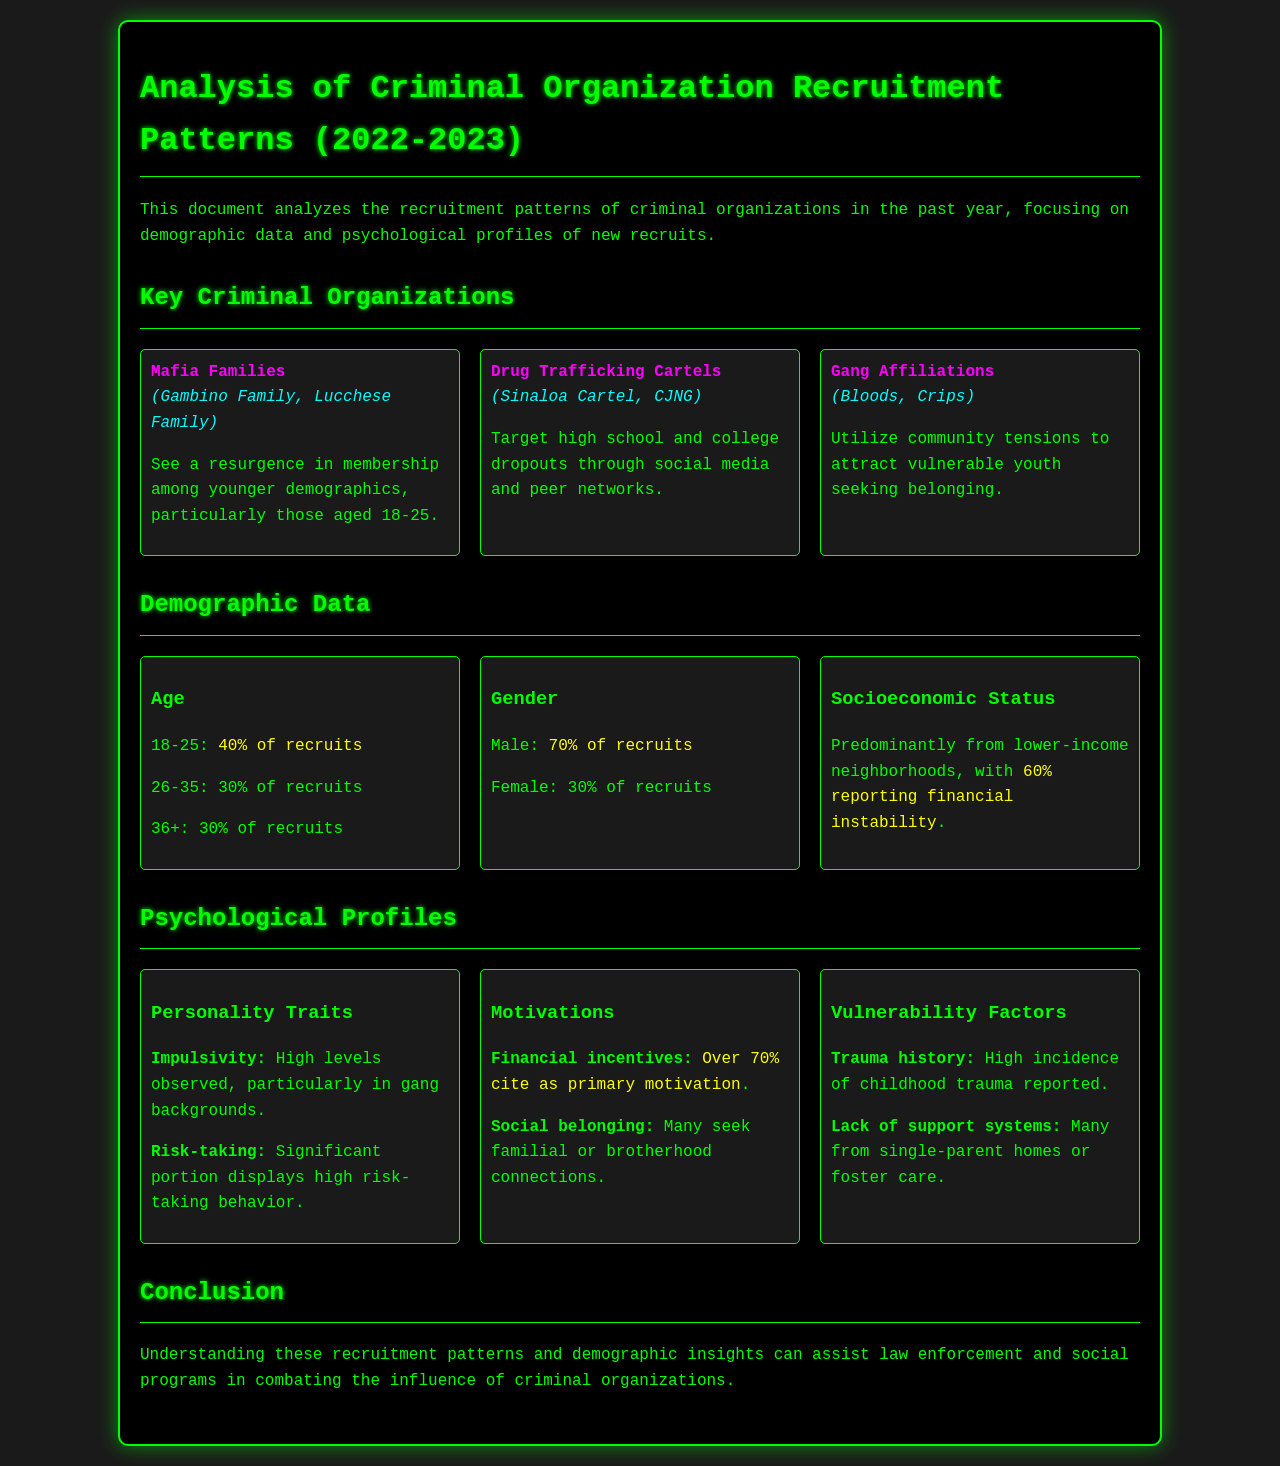what percentage of recruits are aged 18-25? The document states that 40% of recruits are aged 18-25.
Answer: 40% what is the primary motivation for most recruits? Over 70% of recruits cite financial incentives as their primary motivation.
Answer: financial incentives which demographic is predominantly male? The document specifies that 70% of recruits are male.
Answer: 70% what type of organizations see recruitment among younger demographics? The document mentions Mafia Families seeing a resurgence in membership among younger demographics.
Answer: Mafia Families what is a common vulnerability factor among recruits? Many recruits report a high incidence of childhood trauma as a vulnerability factor.
Answer: childhood trauma how many percent of recruits come from lower-income neighborhoods? The document indicates that 60% of recruits report financial instability, implying a connection to socioeconomic status.
Answer: 60% which age group has the same percentage of recruits as those aged 36 and above? The document indicates that 30% of recruits are in the 26-35 age group, which is the same percentage as those who are 36 and older.
Answer: 30% which criminal organization targets high school and college dropouts? The document states that Drug Trafficking Cartels target high school and college dropouts.
Answer: Drug Trafficking Cartels 